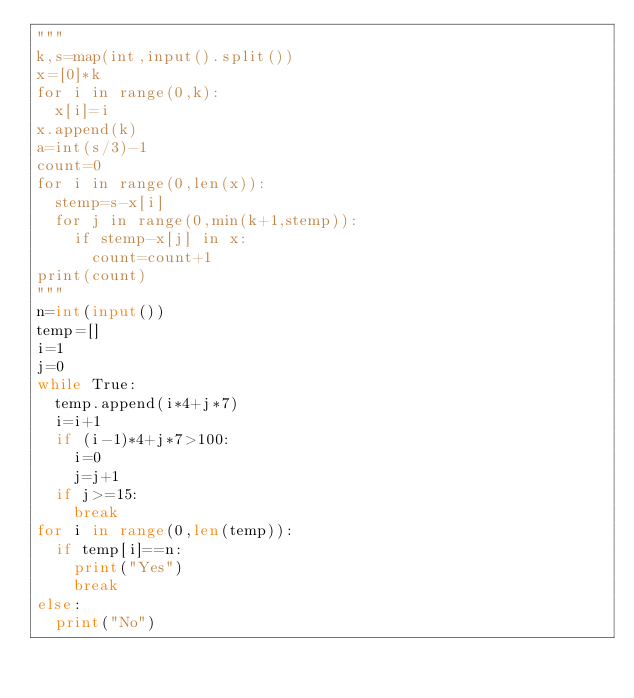Convert code to text. <code><loc_0><loc_0><loc_500><loc_500><_Python_>"""
k,s=map(int,input().split())
x=[0]*k
for i in range(0,k):
  x[i]=i
x.append(k)
a=int(s/3)-1
count=0
for i in range(0,len(x)):
  stemp=s-x[i]
  for j in range(0,min(k+1,stemp)):
    if stemp-x[j] in x:
      count=count+1
print(count)
"""
n=int(input())
temp=[]
i=1
j=0
while True:
  temp.append(i*4+j*7)
  i=i+1
  if (i-1)*4+j*7>100:
    i=0
    j=j+1
  if j>=15:
    break
for i in range(0,len(temp)):
  if temp[i]==n:
    print("Yes")
    break
else:
  print("No")
</code> 